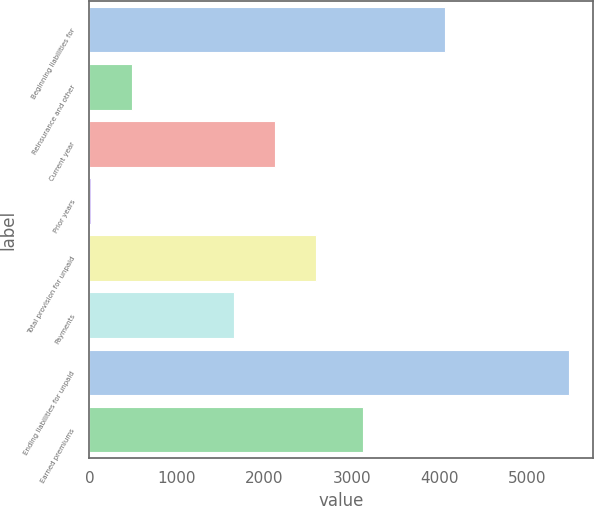Convert chart. <chart><loc_0><loc_0><loc_500><loc_500><bar_chart><fcel>Beginning liabilities for<fcel>Reinsurance and other<fcel>Current year<fcel>Prior years<fcel>Total provision for unpaid<fcel>Payments<fcel>Ending liabilities for unpaid<fcel>Earned premiums<nl><fcel>4065<fcel>491.5<fcel>2121.5<fcel>19<fcel>2594<fcel>1649<fcel>5482.5<fcel>3126<nl></chart> 